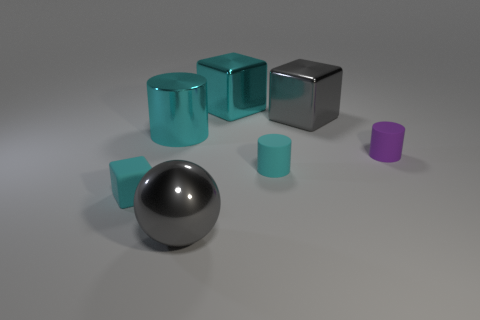Subtract all metallic blocks. How many blocks are left? 1 Subtract all purple cylinders. How many cylinders are left? 2 Subtract 1 spheres. How many spheres are left? 0 Add 1 purple rubber things. How many objects exist? 8 Subtract 0 brown cylinders. How many objects are left? 7 Subtract all cubes. How many objects are left? 4 Subtract all green blocks. Subtract all blue cylinders. How many blocks are left? 3 Subtract all yellow cylinders. How many cyan cubes are left? 2 Subtract all cyan rubber cubes. Subtract all gray balls. How many objects are left? 5 Add 7 matte objects. How many matte objects are left? 10 